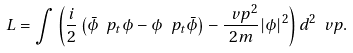Convert formula to latex. <formula><loc_0><loc_0><loc_500><loc_500>L = \int \left ( \frac { i } { 2 } \left ( \bar { \phi } \ p _ { t } \phi - \phi \ p _ { t } \bar { \phi } \right ) - \frac { \ v p ^ { 2 } } { 2 m } | \phi | ^ { 2 } \right ) d ^ { 2 } \ v p .</formula> 